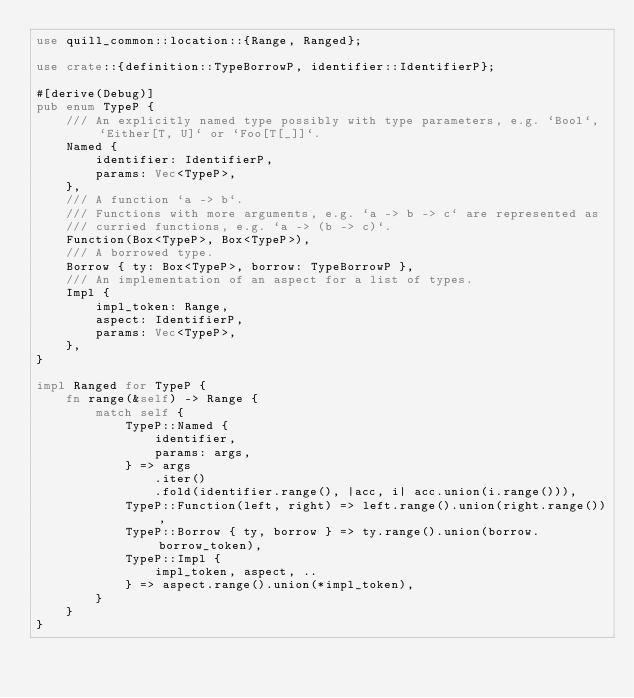Convert code to text. <code><loc_0><loc_0><loc_500><loc_500><_Rust_>use quill_common::location::{Range, Ranged};

use crate::{definition::TypeBorrowP, identifier::IdentifierP};

#[derive(Debug)]
pub enum TypeP {
    /// An explicitly named type possibly with type parameters, e.g. `Bool`, `Either[T, U]` or `Foo[T[_]]`.
    Named {
        identifier: IdentifierP,
        params: Vec<TypeP>,
    },
    /// A function `a -> b`.
    /// Functions with more arguments, e.g. `a -> b -> c` are represented as
    /// curried functions, e.g. `a -> (b -> c)`.
    Function(Box<TypeP>, Box<TypeP>),
    /// A borrowed type.
    Borrow { ty: Box<TypeP>, borrow: TypeBorrowP },
    /// An implementation of an aspect for a list of types.
    Impl {
        impl_token: Range,
        aspect: IdentifierP,
        params: Vec<TypeP>,
    },
}

impl Ranged for TypeP {
    fn range(&self) -> Range {
        match self {
            TypeP::Named {
                identifier,
                params: args,
            } => args
                .iter()
                .fold(identifier.range(), |acc, i| acc.union(i.range())),
            TypeP::Function(left, right) => left.range().union(right.range()),
            TypeP::Borrow { ty, borrow } => ty.range().union(borrow.borrow_token),
            TypeP::Impl {
                impl_token, aspect, ..
            } => aspect.range().union(*impl_token),
        }
    }
}
</code> 